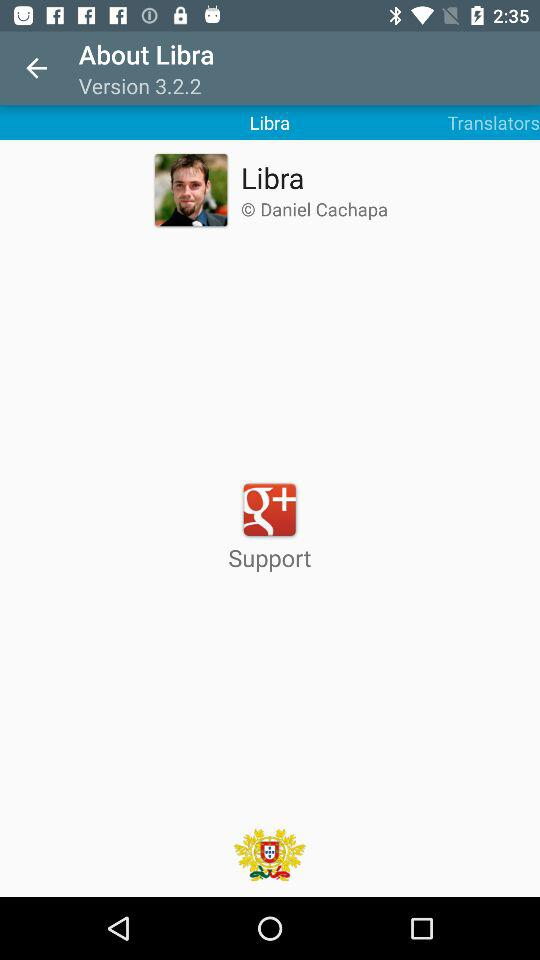What is the name of the user? The name of the user is Daniel Cachapa. 